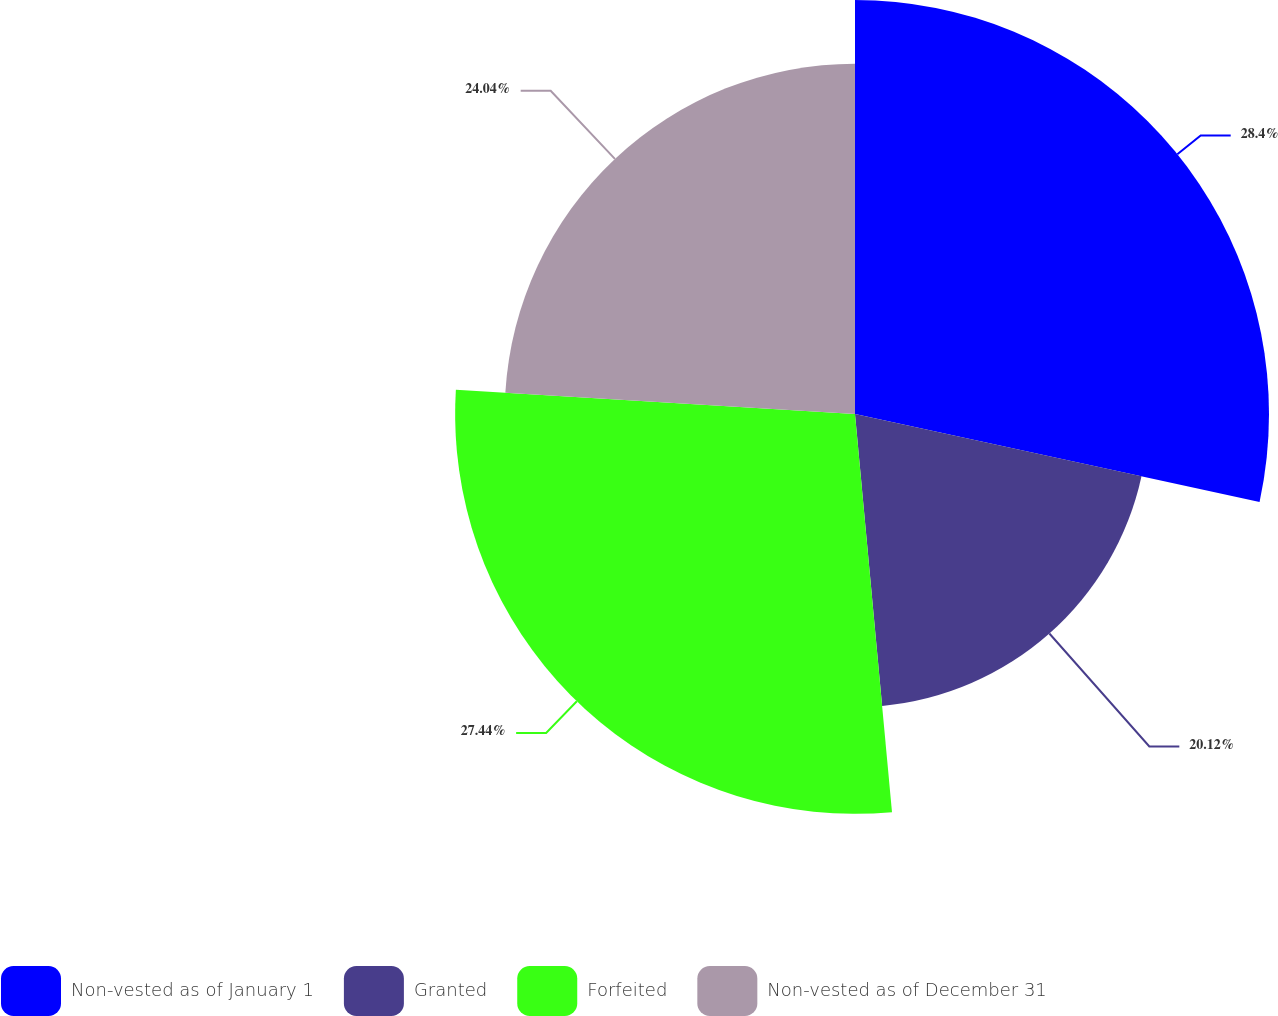Convert chart to OTSL. <chart><loc_0><loc_0><loc_500><loc_500><pie_chart><fcel>Non-vested as of January 1<fcel>Granted<fcel>Forfeited<fcel>Non-vested as of December 31<nl><fcel>28.41%<fcel>20.12%<fcel>27.44%<fcel>24.04%<nl></chart> 